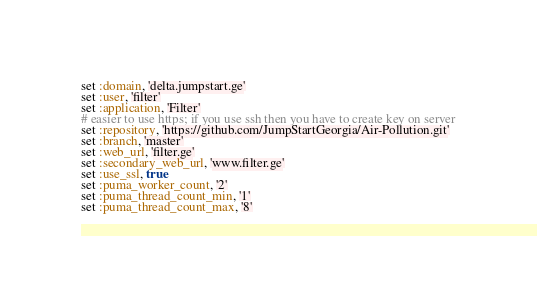<code> <loc_0><loc_0><loc_500><loc_500><_Ruby_>set :domain, 'delta.jumpstart.ge'
set :user, 'filter'
set :application, 'Filter'
# easier to use https; if you use ssh then you have to create key on server
set :repository, 'https://github.com/JumpStartGeorgia/Air-Pollution.git'
set :branch, 'master'
set :web_url, 'filter.ge'
set :secondary_web_url, 'www.filter.ge'
set :use_ssl, true
set :puma_worker_count, '2'
set :puma_thread_count_min, '1'
set :puma_thread_count_max, '8'

</code> 